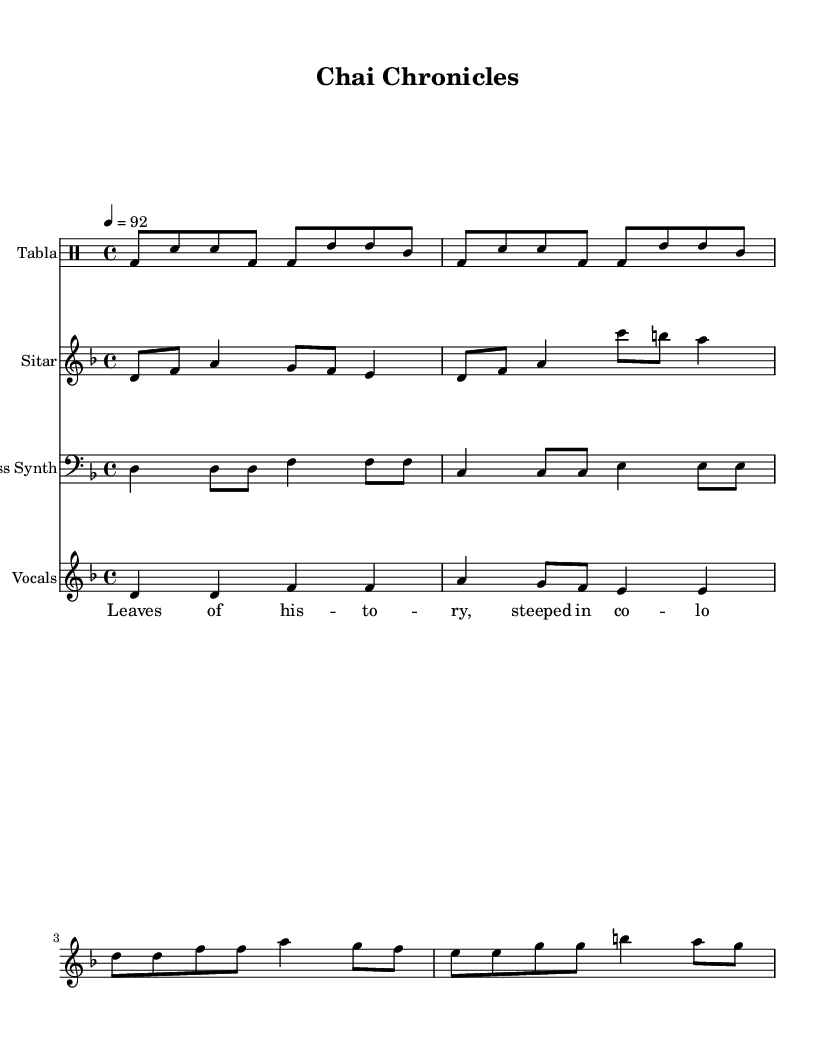What is the key signature of this music? The key signature is D minor, which has one flat (B flat). This can be determined by looking at the accidentals presented on the staff in the music score.
Answer: D minor What is the time signature of this music? The time signature is 4/4, as indicated at the beginning of the score. This means there are four beats per measure.
Answer: 4/4 What is the tempo marking for this music? The tempo marking is 92 beats per minute, as stated at the beginning of the score with tempo indication.
Answer: 92 How many measures are there in the tabla section? There are four measures in the tabla section. This can be counted by looking at the notation in the drum staff and observing the grouping of beats.
Answer: 4 Which instrument has the most visible melodic line? The sitar has the most visible melodic line, evident by the ascending and descending notes written in the treble clef.
Answer: Sitar What lyrical theme does the song’s lyrics convey? The lyrics convey a theme of colonialism and its impact on the tea trade, reflecting on the bitterness and sweetness of the legacy. This is inferred from the specific words used in the lyrics.
Answer: Colonialism What type of music genre does this piece belong to based on its characteristics? This piece belongs to the Hip Hop genre, as it features modern beats and incorporates spoken lyrics which is characteristic of Hip Hop music.
Answer: Hip Hop 